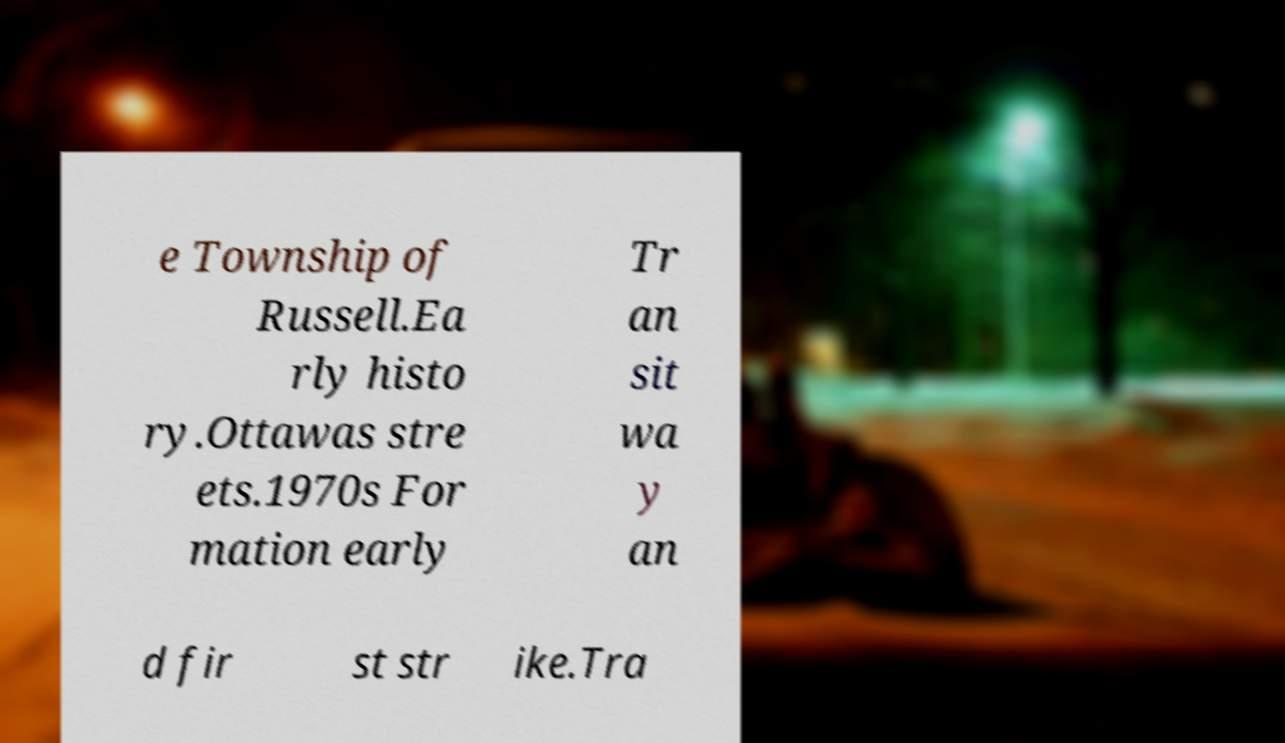What messages or text are displayed in this image? I need them in a readable, typed format. e Township of Russell.Ea rly histo ry.Ottawas stre ets.1970s For mation early Tr an sit wa y an d fir st str ike.Tra 